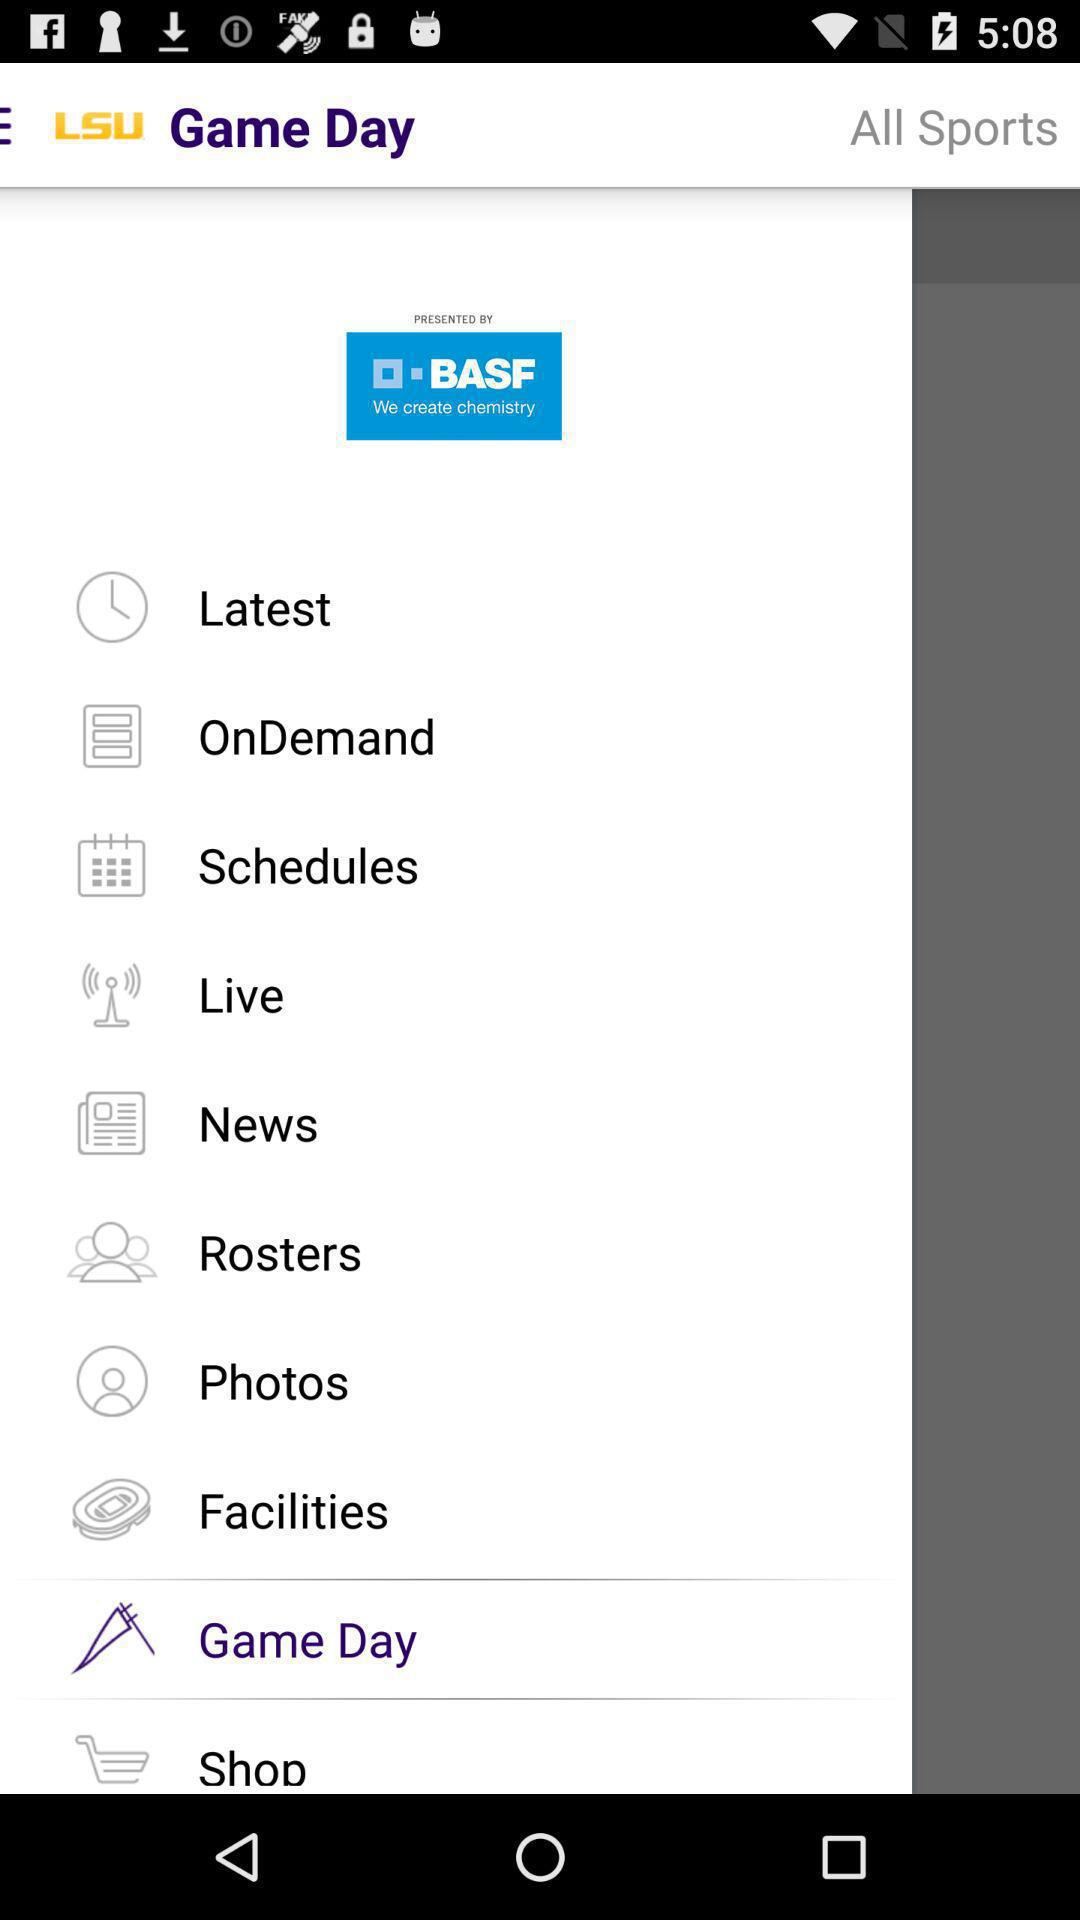What is the name of the application? The name of the application is "LSU". 